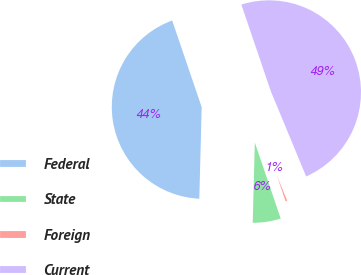Convert chart to OTSL. <chart><loc_0><loc_0><loc_500><loc_500><pie_chart><fcel>Federal<fcel>State<fcel>Foreign<fcel>Current<nl><fcel>44.36%<fcel>5.64%<fcel>1.03%<fcel>48.97%<nl></chart> 